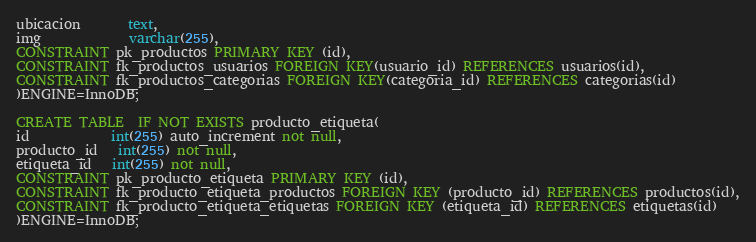Convert code to text. <code><loc_0><loc_0><loc_500><loc_500><_SQL_>ubicacion       text,
img             varchar(255),
CONSTRAINT pk_productos PRIMARY KEY (id),
CONSTRAINT fk_productos_usuarios FOREIGN KEY(usuario_id) REFERENCES usuarios(id),
CONSTRAINT fk_productos_categorias FOREIGN KEY(categoria_id) REFERENCES categorias(id)
)ENGINE=InnoDB;

CREATE TABLE  IF NOT EXISTS producto_etiqueta(
id            int(255) auto_increment not null,
producto_id   int(255) not null,
etiqueta_id   int(255) not null,
CONSTRAINT pk_producto_etiqueta PRIMARY KEY (id),
CONSTRAINT fk_producto_etiqueta_productos FOREIGN KEY (producto_id) REFERENCES productos(id),
CONSTRAINT fk_producto_etiqueta_etiquetas FOREIGN KEY (etiqueta_id) REFERENCES etiquetas(id)
)ENGINE=InnoDB;</code> 